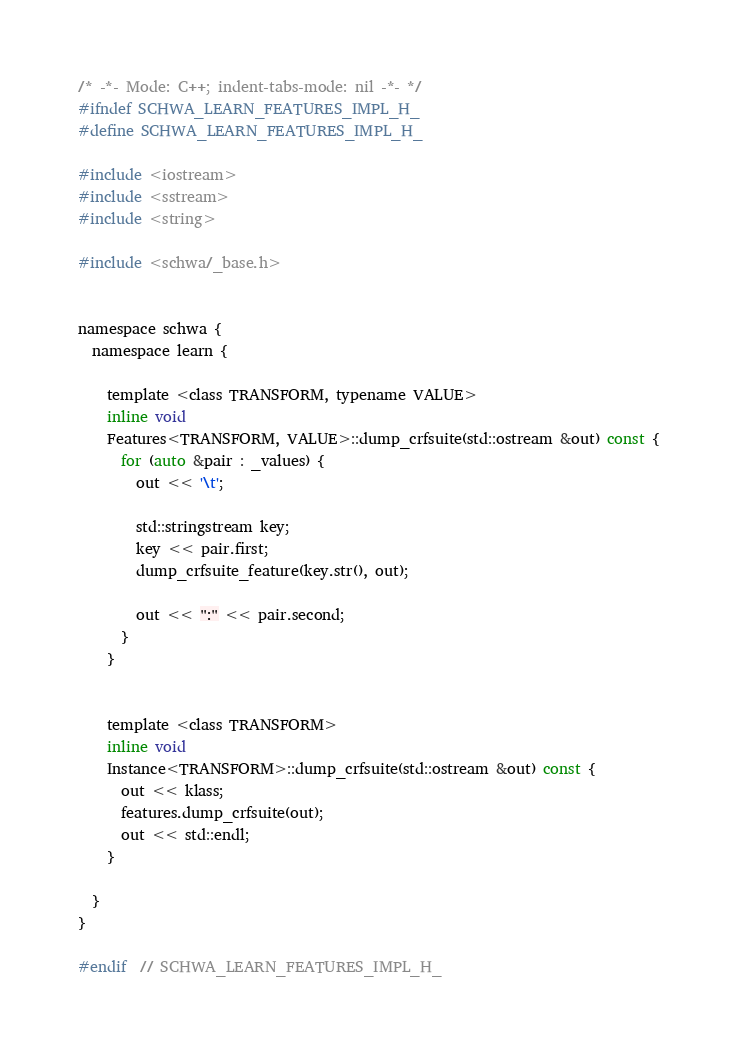<code> <loc_0><loc_0><loc_500><loc_500><_C_>/* -*- Mode: C++; indent-tabs-mode: nil -*- */
#ifndef SCHWA_LEARN_FEATURES_IMPL_H_
#define SCHWA_LEARN_FEATURES_IMPL_H_

#include <iostream>
#include <sstream>
#include <string>

#include <schwa/_base.h>


namespace schwa {
  namespace learn {

    template <class TRANSFORM, typename VALUE>
    inline void
    Features<TRANSFORM, VALUE>::dump_crfsuite(std::ostream &out) const {
      for (auto &pair : _values) {
        out << '\t';

        std::stringstream key;
        key << pair.first;
        dump_crfsuite_feature(key.str(), out);

        out << ":" << pair.second;
      }
    }


    template <class TRANSFORM>
    inline void
    Instance<TRANSFORM>::dump_crfsuite(std::ostream &out) const {
      out << klass;
      features.dump_crfsuite(out);
      out << std::endl;
    }

  }
}

#endif  // SCHWA_LEARN_FEATURES_IMPL_H_
</code> 